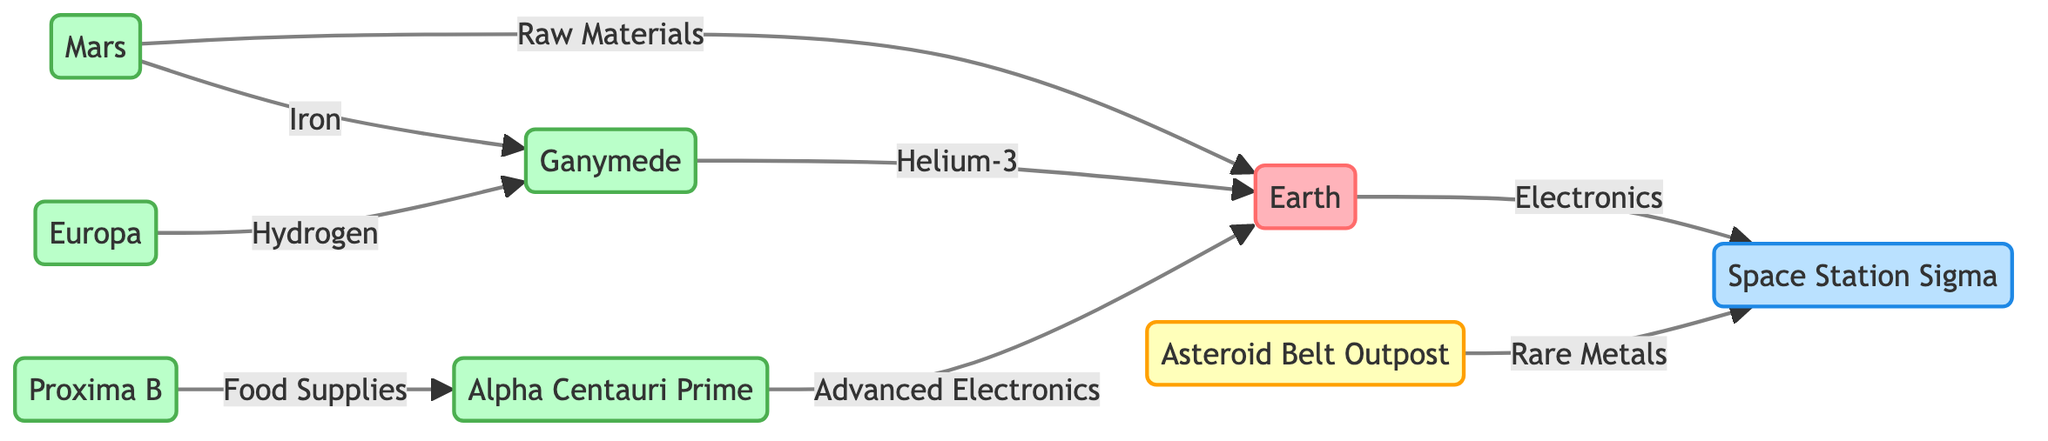What is the central hub of trade? In the diagram, the "Earth" is labeled as the central hub of trade and resource distribution, making it the focal point for connections to other colonies.
Answer: Earth How many planets are there in the diagram? The diagram features one designated planet, Earth, while the others are specified as colonies or outposts, indicating there is only one planet present.
Answer: 1 What resource does Mars supply to Earth? The edge labeled "Raw Materials" flows from "Mars" to "Earth," indicating that Mars is the supplier of raw materials specifically to Earth.
Answer: Raw Materials Which colony supplies hydrogen to Ganymede? The flow from "Europa" to "Ganymede" is labeled with the resource "Hydrogen," which specifies that Europa is the colony supplying this resource to Ganymede.
Answer: Europa Which planetary colony is responsible for supplying food supplies? The connection indicates that "Proxima B" provides "Food Supplies" to "Alpha Centauri Prime," thus identifying Proxima B as the source for food supplies.
Answer: Proxima B What type of transport is used from Earth to Space Station Sigma? The edge from "Earth" to "Space Station Sigma" specifies that "Cargo Shuttle" is the transport method employed for this flow of resources.
Answer: Cargo Shuttle What is Ganymede's primary resource exported to Earth? The flow from "Ganymede" to "Earth" is marked with "Helium-3," identifying it as the primary resource that Ganymede exports to Earth.
Answer: Helium-3 How many total edges connect the nodes? By counting each directed connection (edge) in the diagram, we find that there are a total of eight connections between the various nodes and their resources.
Answer: 8 Which outpost mines for rare metals? The "Asteroid Belt Outpost" is labeled in the description as a mining colony, specifically indicating it mines for rare metals and elements from asteroids.
Answer: Asteroid Belt Outpost 